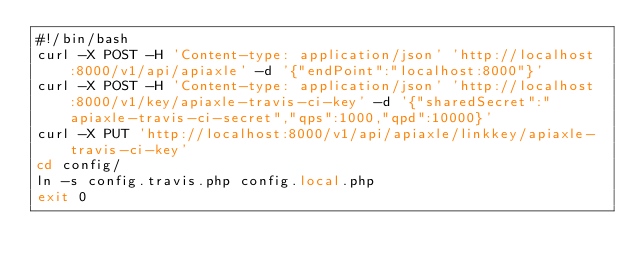<code> <loc_0><loc_0><loc_500><loc_500><_Bash_>#!/bin/bash
curl -X POST -H 'Content-type: application/json' 'http://localhost:8000/v1/api/apiaxle' -d '{"endPoint":"localhost:8000"}'
curl -X POST -H 'Content-type: application/json' 'http://localhost:8000/v1/key/apiaxle-travis-ci-key' -d '{"sharedSecret":"apiaxle-travis-ci-secret","qps":1000,"qpd":10000}'
curl -X PUT 'http://localhost:8000/v1/api/apiaxle/linkkey/apiaxle-travis-ci-key'
cd config/
ln -s config.travis.php config.local.php
exit 0
</code> 